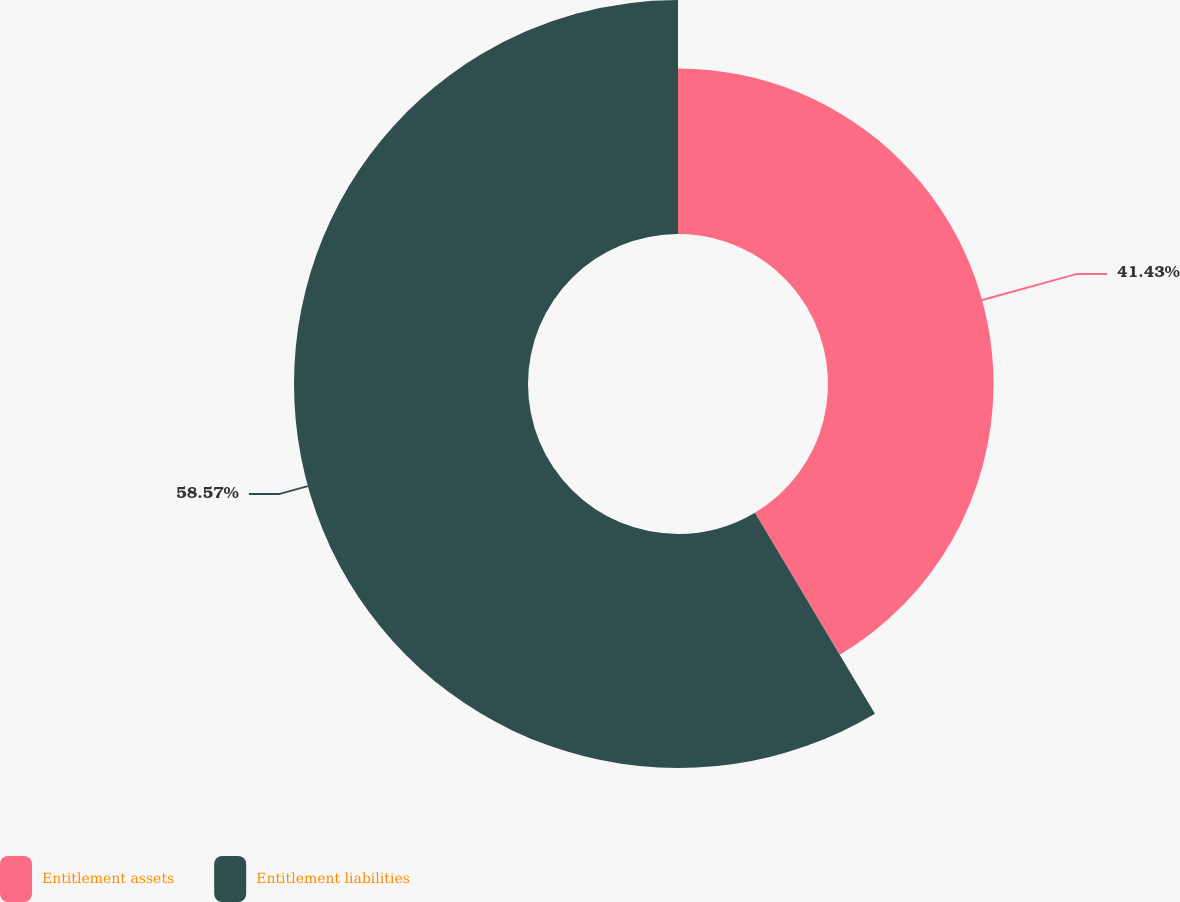Convert chart to OTSL. <chart><loc_0><loc_0><loc_500><loc_500><pie_chart><fcel>Entitlement assets<fcel>Entitlement liabilities<nl><fcel>41.43%<fcel>58.57%<nl></chart> 